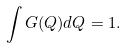<formula> <loc_0><loc_0><loc_500><loc_500>\int G ( { Q } ) d { Q } = 1 .</formula> 